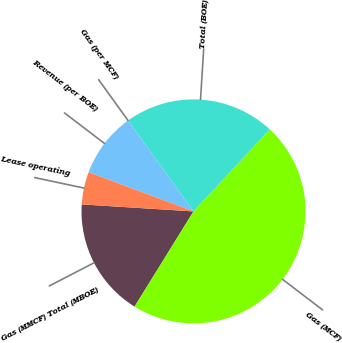Convert chart to OTSL. <chart><loc_0><loc_0><loc_500><loc_500><pie_chart><fcel>Gas (MMCF) Total (MBOE)<fcel>Gas (MCF)<fcel>Total (BOE)<fcel>Gas (per MCF)<fcel>Revenue (per BOE)<fcel>Lease operating<nl><fcel>17.17%<fcel>46.9%<fcel>21.86%<fcel>0.0%<fcel>9.38%<fcel>4.69%<nl></chart> 